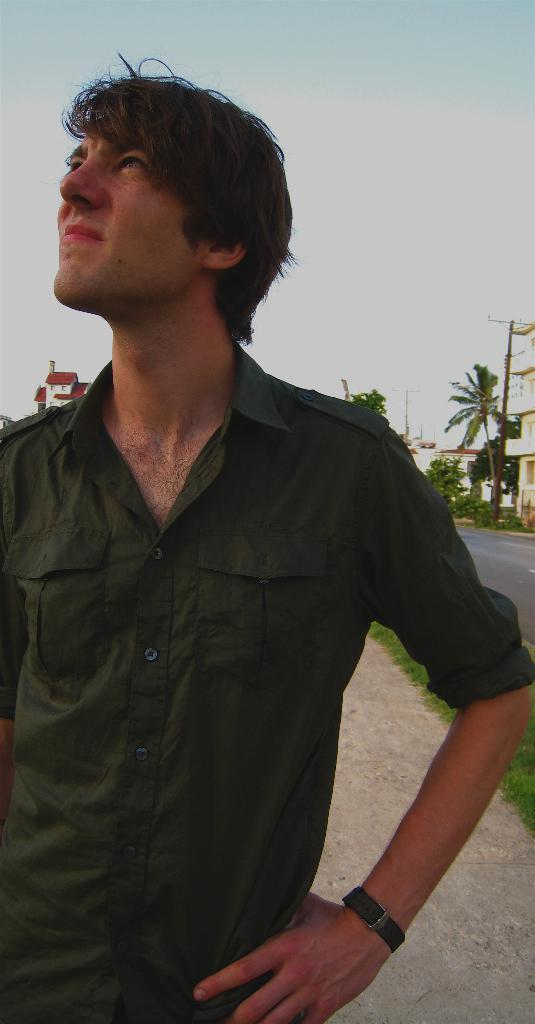Who is present in the image? There is a man in the image. What is the man wearing? The man is wearing a green shirt. What can be seen in the background of the image? There are trees, a building, and the sky visible in the background of the image. What type of metal is the man's toes made of in the image? The image does not show the man's toes, nor does it mention anything about metal. 